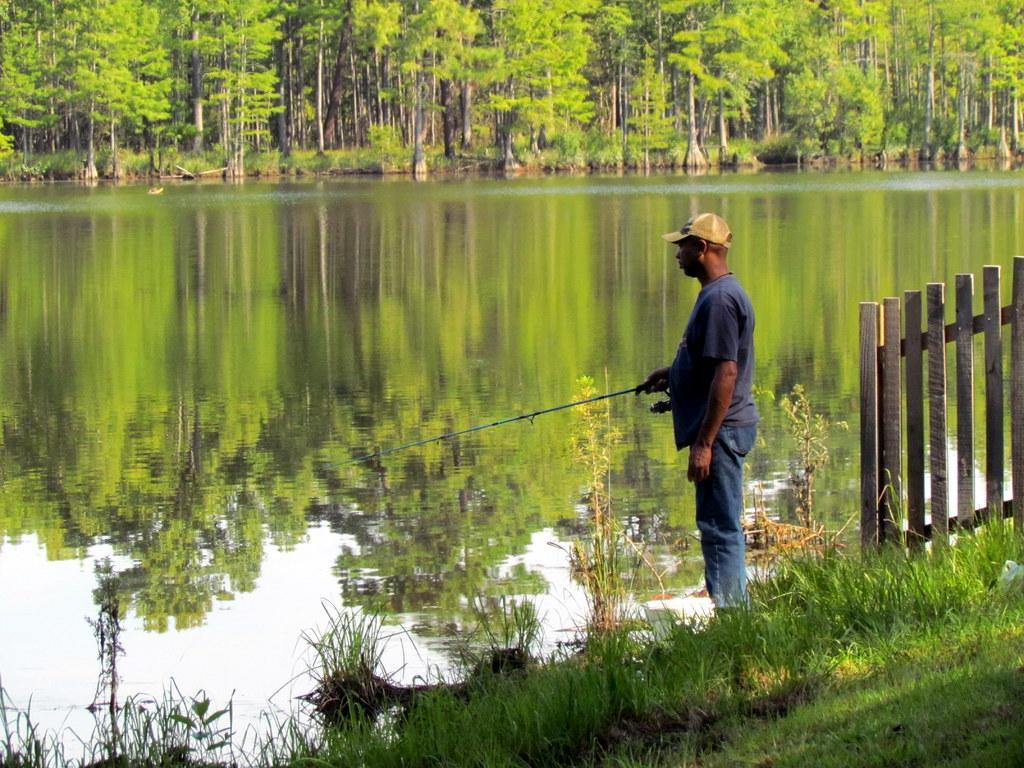Describe this image in one or two sentences. In this image we can see a person standing and holding an object. Behind the person we can see the water and a group of trees. On the water we can see the reflection of trees and the sky. In the foreground we have grass and a wooden fence. 